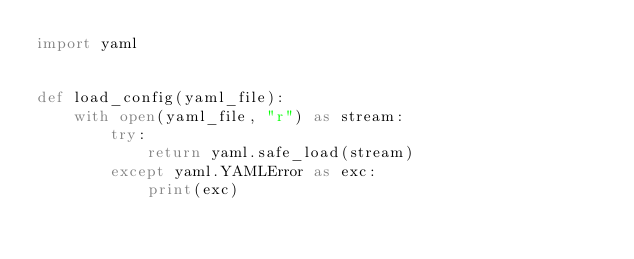Convert code to text. <code><loc_0><loc_0><loc_500><loc_500><_Python_>import yaml


def load_config(yaml_file):
    with open(yaml_file, "r") as stream:
        try:
            return yaml.safe_load(stream)
        except yaml.YAMLError as exc:
            print(exc)</code> 